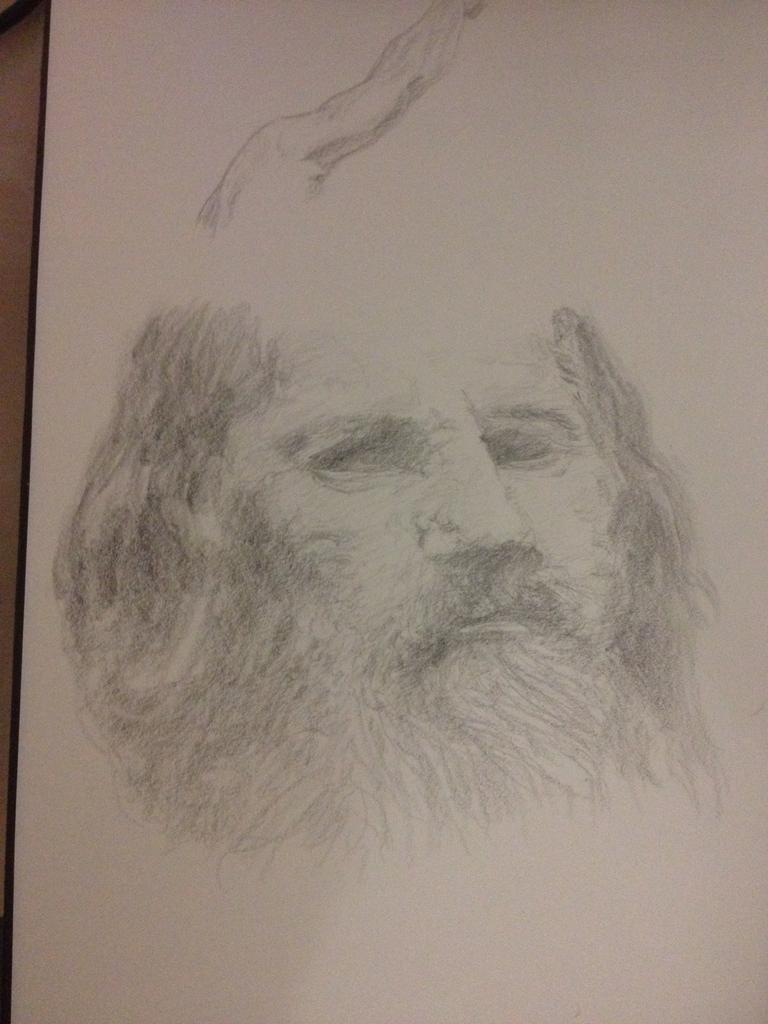What is the main subject of the image? There is a white object in the image. What is depicted on the white object? The white object has a sketch of a person's face on it. What type of quill is being used to draw the person's face on the white object? There is no quill present in the image, and the person's face is already sketched on the white object. How much milk is being poured onto the white object in the image? There is no milk present in the image. 